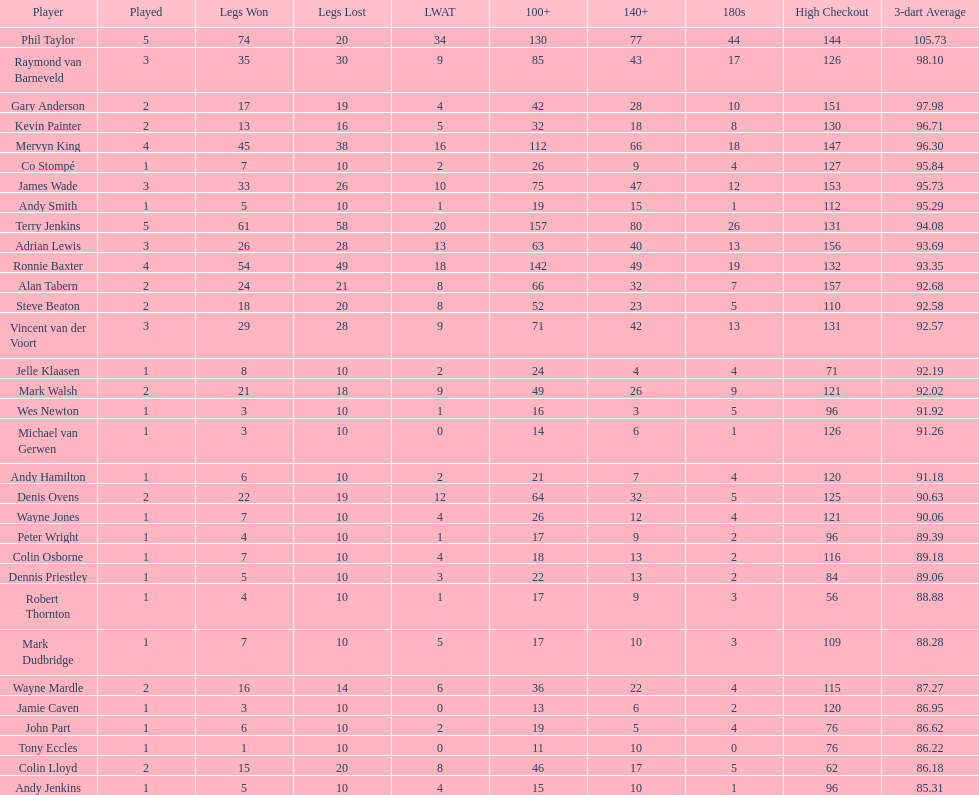Which player has his high checkout as 116? Colin Osborne. 